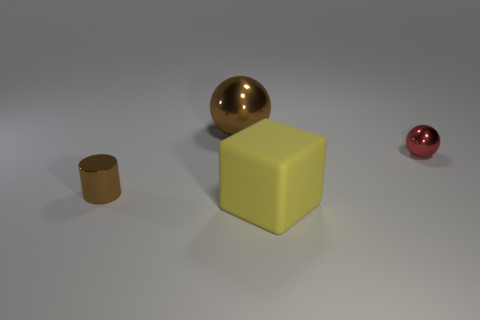Is the rubber thing the same shape as the small red thing?
Offer a very short reply. No. Is there a large object that has the same color as the tiny metal cylinder?
Make the answer very short. Yes. What shape is the large object that is behind the tiny red shiny ball?
Your answer should be very brief. Sphere. The cylinder has what color?
Your response must be concise. Brown. The cylinder that is made of the same material as the small sphere is what color?
Ensure brevity in your answer.  Brown. How many cylinders have the same material as the yellow cube?
Your response must be concise. 0. How many big brown objects are to the left of the big brown metal object?
Your response must be concise. 0. Do the small object on the right side of the yellow matte block and the small thing that is to the left of the yellow thing have the same material?
Ensure brevity in your answer.  Yes. Are there more brown objects left of the big brown metal sphere than big metallic objects that are in front of the small red thing?
Offer a very short reply. Yes. There is a large sphere that is the same color as the cylinder; what material is it?
Your answer should be compact. Metal. 